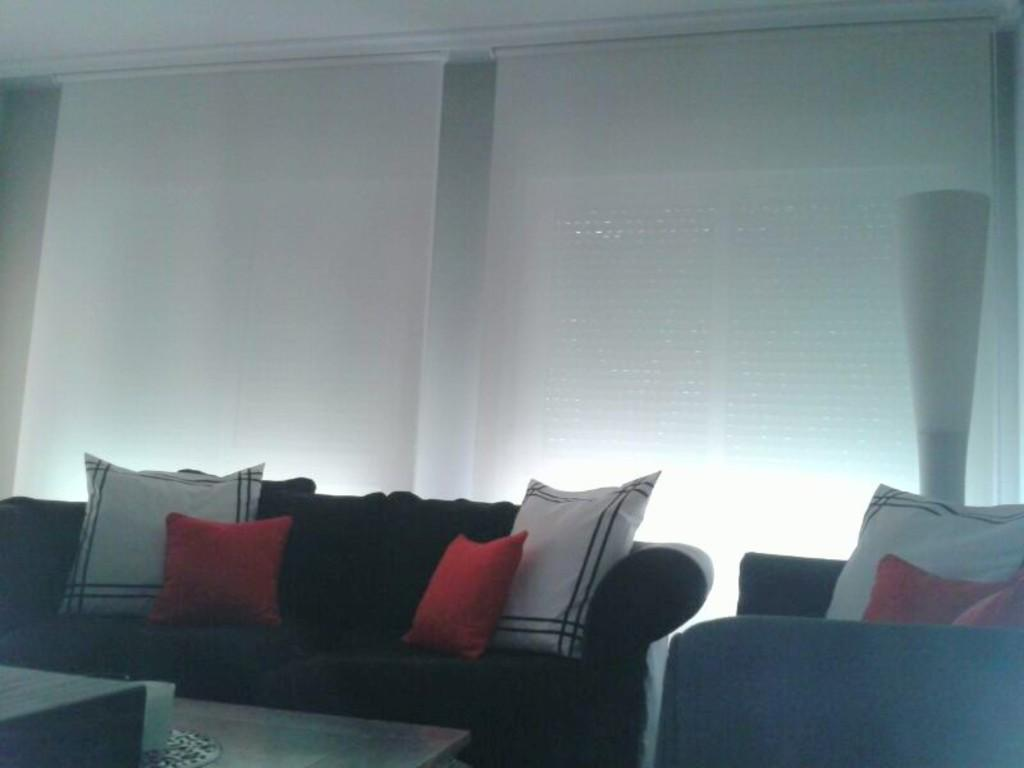What type of space is depicted in the image? There is a room in the image. What furniture is present in the room? There is a sofa with pillows and a table in the room. What can be found on the table? There is a glass on the table. What can be seen in the background of the image? There are windows visible in the background of the image. What type of veil is draped over the sofa in the image? There is no veil present in the image; the sofa has pillows on it. 